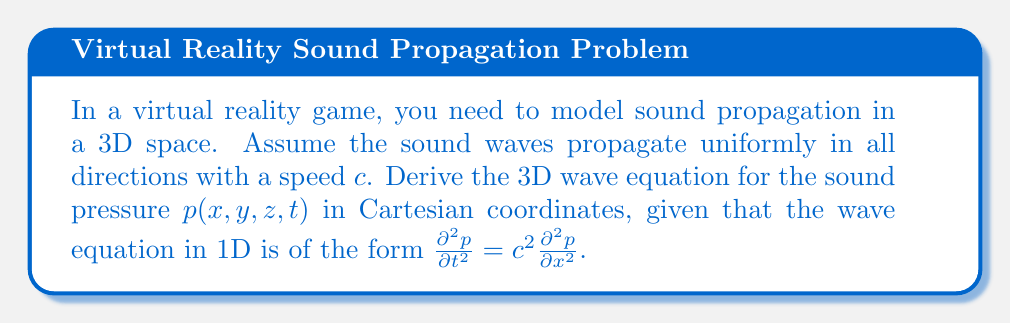Could you help me with this problem? To derive the 3D wave equation for sound propagation, we need to extend the 1D wave equation to three dimensions. Let's approach this step-by-step:

1) The 1D wave equation is given as:

   $$\frac{\partial^2 p}{\partial t^2} = c^2 \frac{\partial^2 p}{\partial x^2}$$

2) In 3D, we need to consider the propagation of sound in all three spatial dimensions (x, y, and z). The principle is the same, but we need to include partial derivatives with respect to y and z as well.

3) For the x-direction, the equation remains the same:

   $$\frac{\partial^2 p}{\partial t^2} = c^2 \frac{\partial^2 p}{\partial x^2}$$

4) For the y-direction, we have:

   $$\frac{\partial^2 p}{\partial t^2} = c^2 \frac{\partial^2 p}{\partial y^2}$$

5) And for the z-direction:

   $$\frac{\partial^2 p}{\partial t^2} = c^2 \frac{\partial^2 p}{\partial z^2}$$

6) Since the sound propagates uniformly in all directions, we can combine these equations by adding the right-hand sides:

   $$\frac{\partial^2 p}{\partial t^2} = c^2 \left(\frac{\partial^2 p}{\partial x^2} + \frac{\partial^2 p}{\partial y^2} + \frac{\partial^2 p}{\partial z^2}\right)$$

7) The term in parentheses is the Laplacian operator in 3D Cartesian coordinates, often denoted as $\nabla^2$:

   $$\nabla^2 p = \frac{\partial^2 p}{\partial x^2} + \frac{\partial^2 p}{\partial y^2} + \frac{\partial^2 p}{\partial z^2}$$

8) Therefore, we can write the 3D wave equation in its final form:

   $$\frac{\partial^2 p}{\partial t^2} = c^2 \nabla^2 p$$

This equation models how the sound pressure $p$ changes in 3D space and time, which is crucial for realistic sound propagation in a virtual reality environment.
Answer: The 3D wave equation for sound propagation in Cartesian coordinates is:

$$\frac{\partial^2 p}{\partial t^2} = c^2 \left(\frac{\partial^2 p}{\partial x^2} + \frac{\partial^2 p}{\partial y^2} + \frac{\partial^2 p}{\partial z^2}\right)$$

or equivalently:

$$\frac{\partial^2 p}{\partial t^2} = c^2 \nabla^2 p$$

where $p(x,y,z,t)$ is the sound pressure, $c$ is the speed of sound, and $\nabla^2$ is the Laplacian operator in 3D. 